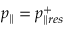Convert formula to latex. <formula><loc_0><loc_0><loc_500><loc_500>p _ { \| } = p _ { \| r e s } ^ { + }</formula> 